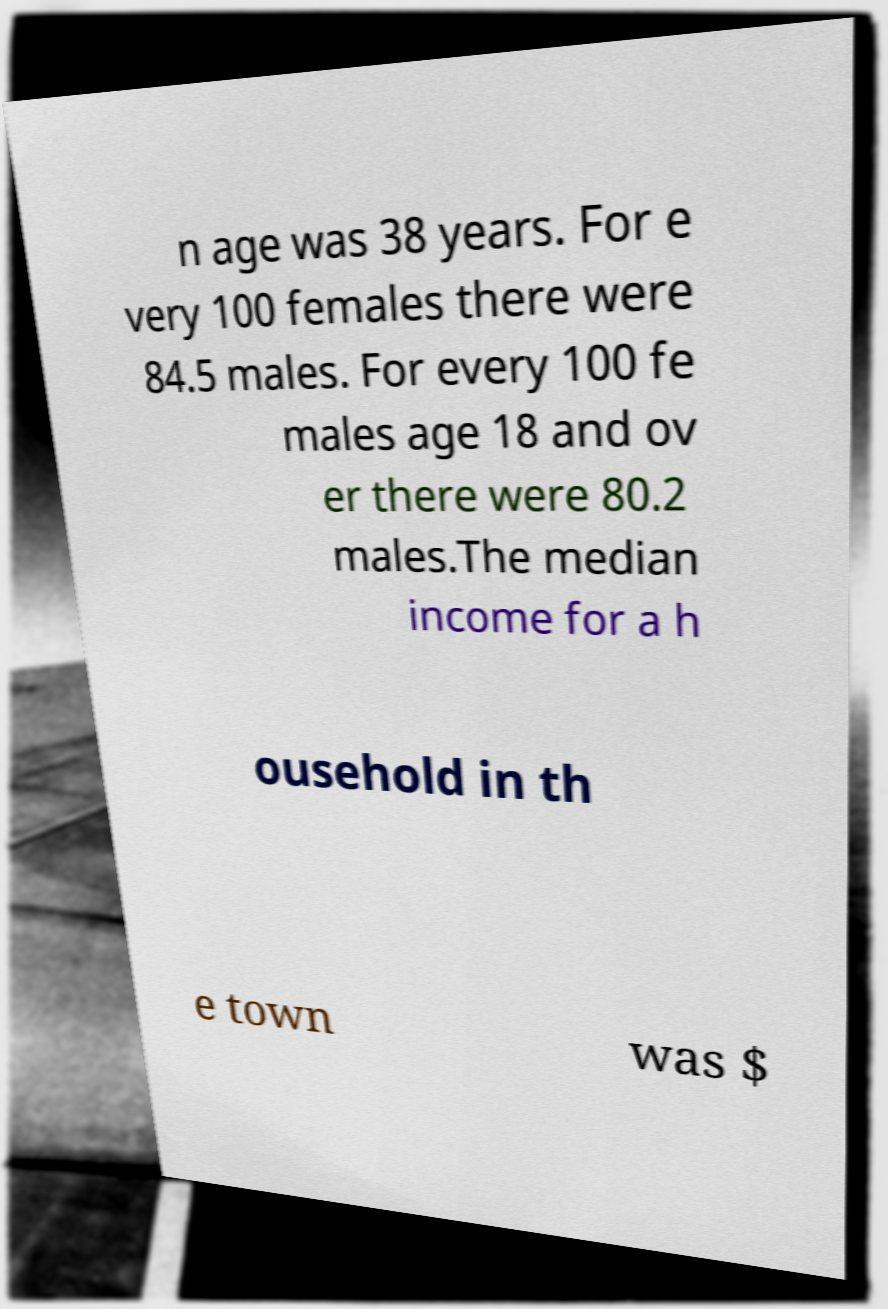For documentation purposes, I need the text within this image transcribed. Could you provide that? n age was 38 years. For e very 100 females there were 84.5 males. For every 100 fe males age 18 and ov er there were 80.2 males.The median income for a h ousehold in th e town was $ 